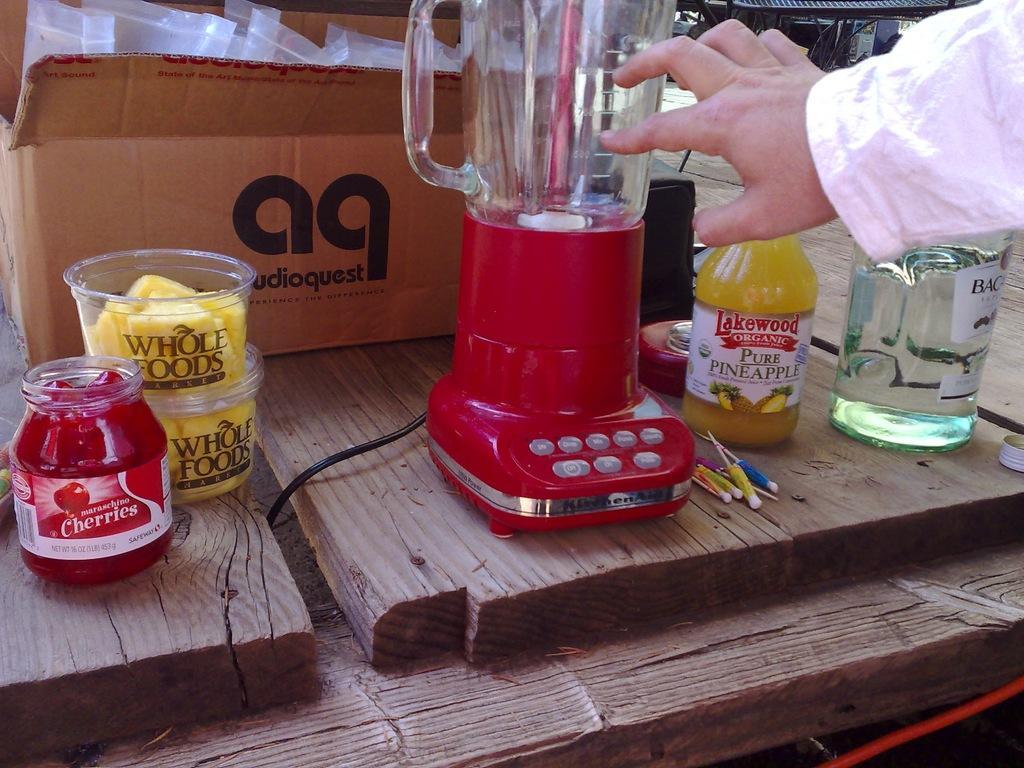Please provide a concise description of this image. In the center we can see mixer,In the left corner we can see sauce bottle named as "cherries". Beside it we can see some food named as "whole food". And back of them there is a box it is named as "Audio quest". And beside the mixer there is a water bottle named as "Take food". And the right corner we can see the water bottle. And on the top right side we can see the human hand holding the mixer. 